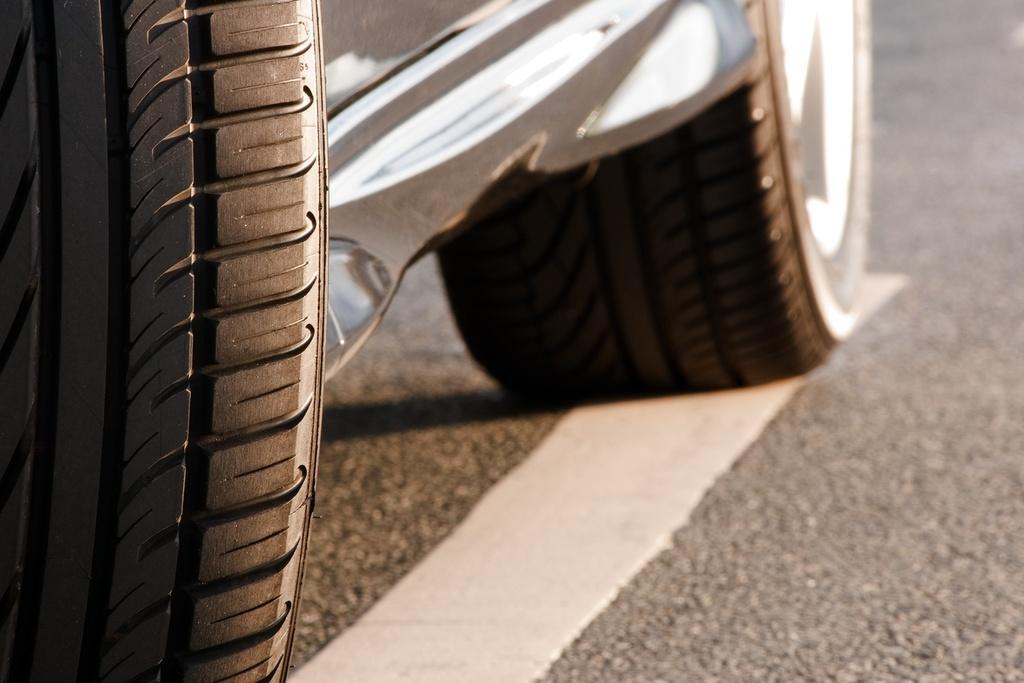How would you summarize this image in a sentence or two? This is the picture of a car, at the bottom. On the right it is road. The background is blurred. 